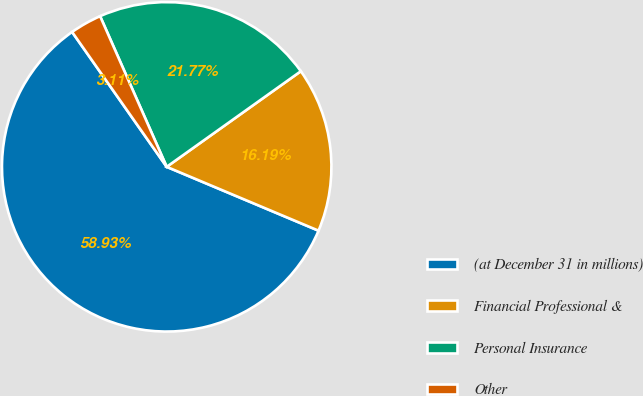Convert chart to OTSL. <chart><loc_0><loc_0><loc_500><loc_500><pie_chart><fcel>(at December 31 in millions)<fcel>Financial Professional &<fcel>Personal Insurance<fcel>Other<nl><fcel>58.93%<fcel>16.19%<fcel>21.77%<fcel>3.11%<nl></chart> 